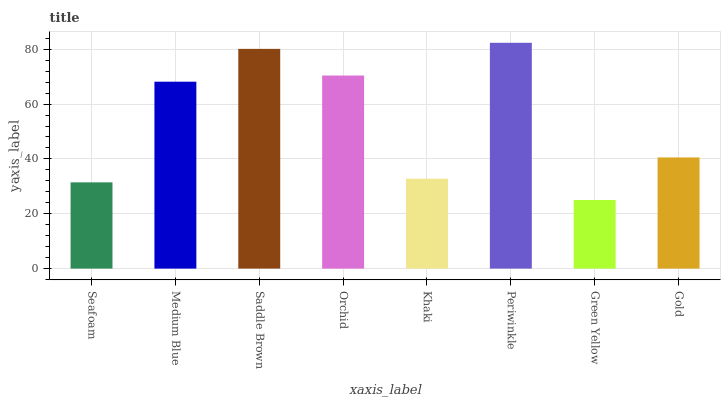Is Green Yellow the minimum?
Answer yes or no. Yes. Is Periwinkle the maximum?
Answer yes or no. Yes. Is Medium Blue the minimum?
Answer yes or no. No. Is Medium Blue the maximum?
Answer yes or no. No. Is Medium Blue greater than Seafoam?
Answer yes or no. Yes. Is Seafoam less than Medium Blue?
Answer yes or no. Yes. Is Seafoam greater than Medium Blue?
Answer yes or no. No. Is Medium Blue less than Seafoam?
Answer yes or no. No. Is Medium Blue the high median?
Answer yes or no. Yes. Is Gold the low median?
Answer yes or no. Yes. Is Green Yellow the high median?
Answer yes or no. No. Is Periwinkle the low median?
Answer yes or no. No. 